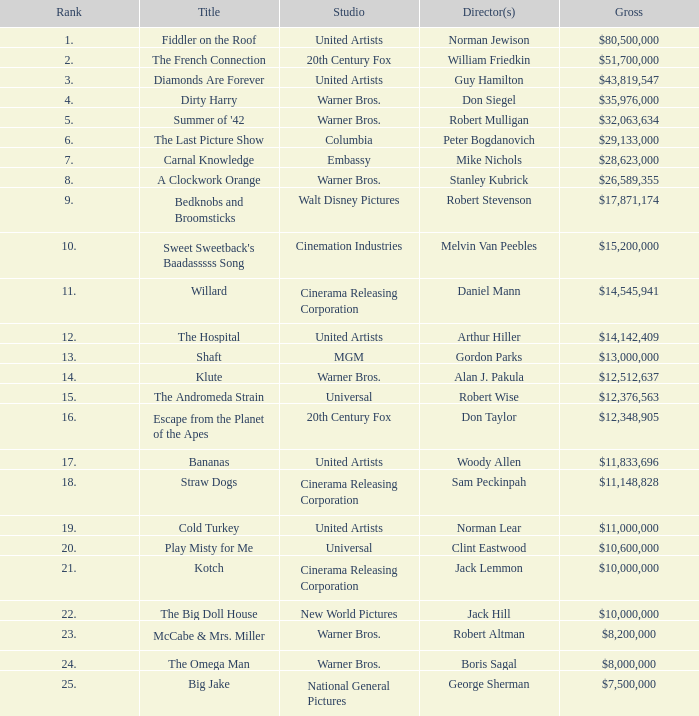Which title ranked lower than 19 has a gross of $11,833,696? Bananas. 